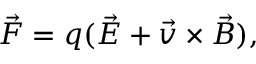<formula> <loc_0><loc_0><loc_500><loc_500>\vec { F } = q ( \vec { E } + \vec { v } \times \vec { B } ) ,</formula> 